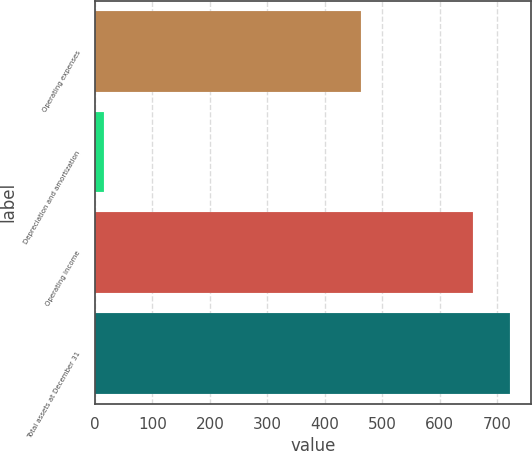Convert chart. <chart><loc_0><loc_0><loc_500><loc_500><bar_chart><fcel>Operating expenses<fcel>Depreciation and amortization<fcel>Operating income<fcel>Total assets at December 31<nl><fcel>462.2<fcel>15.4<fcel>657.1<fcel>722.86<nl></chart> 